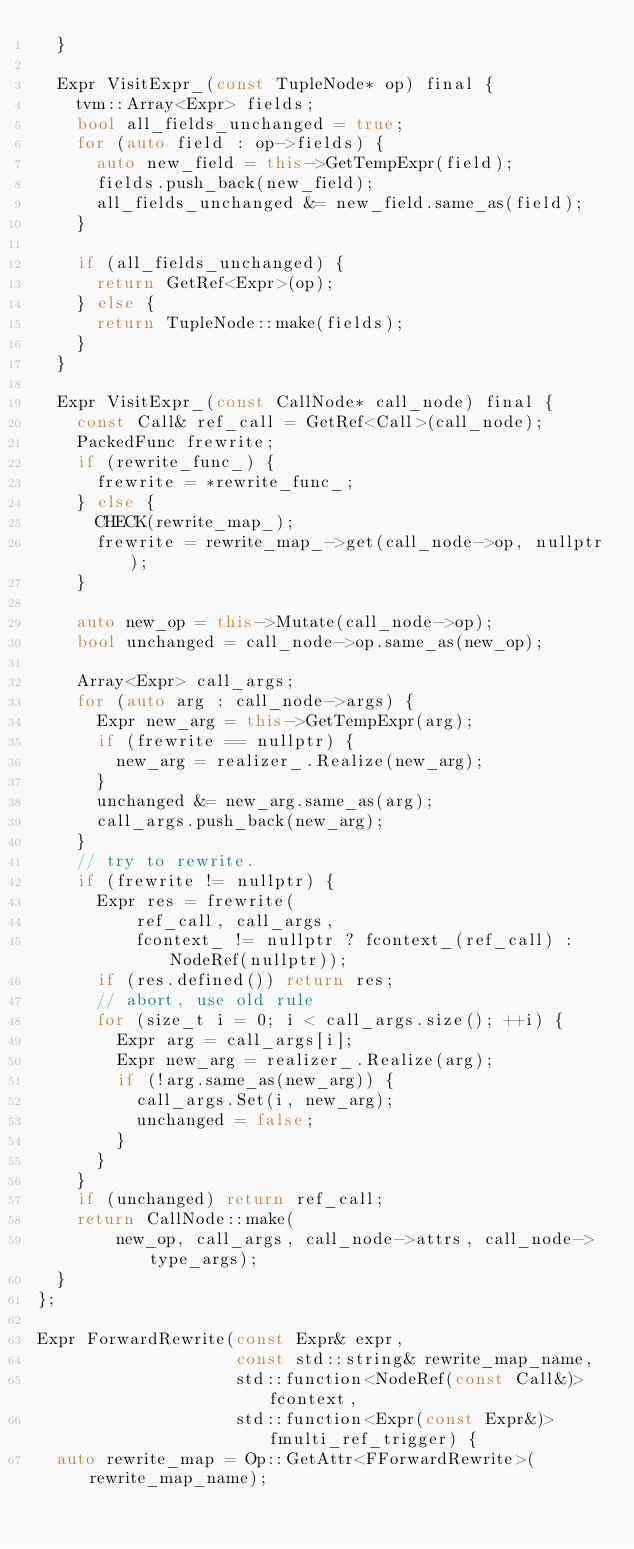<code> <loc_0><loc_0><loc_500><loc_500><_C++_>  }

  Expr VisitExpr_(const TupleNode* op) final {
    tvm::Array<Expr> fields;
    bool all_fields_unchanged = true;
    for (auto field : op->fields) {
      auto new_field = this->GetTempExpr(field);
      fields.push_back(new_field);
      all_fields_unchanged &= new_field.same_as(field);
    }

    if (all_fields_unchanged) {
      return GetRef<Expr>(op);
    } else {
      return TupleNode::make(fields);
    }
  }

  Expr VisitExpr_(const CallNode* call_node) final {
    const Call& ref_call = GetRef<Call>(call_node);
    PackedFunc frewrite;
    if (rewrite_func_) {
      frewrite = *rewrite_func_;
    } else {
      CHECK(rewrite_map_);
      frewrite = rewrite_map_->get(call_node->op, nullptr);
    }

    auto new_op = this->Mutate(call_node->op);
    bool unchanged = call_node->op.same_as(new_op);

    Array<Expr> call_args;
    for (auto arg : call_node->args) {
      Expr new_arg = this->GetTempExpr(arg);
      if (frewrite == nullptr) {
        new_arg = realizer_.Realize(new_arg);
      }
      unchanged &= new_arg.same_as(arg);
      call_args.push_back(new_arg);
    }
    // try to rewrite.
    if (frewrite != nullptr) {
      Expr res = frewrite(
          ref_call, call_args,
          fcontext_ != nullptr ? fcontext_(ref_call) : NodeRef(nullptr));
      if (res.defined()) return res;
      // abort, use old rule
      for (size_t i = 0; i < call_args.size(); ++i) {
        Expr arg = call_args[i];
        Expr new_arg = realizer_.Realize(arg);
        if (!arg.same_as(new_arg)) {
          call_args.Set(i, new_arg);
          unchanged = false;
        }
      }
    }
    if (unchanged) return ref_call;
    return CallNode::make(
        new_op, call_args, call_node->attrs, call_node->type_args);
  }
};

Expr ForwardRewrite(const Expr& expr,
                    const std::string& rewrite_map_name,
                    std::function<NodeRef(const Call&)> fcontext,
                    std::function<Expr(const Expr&)> fmulti_ref_trigger) {
  auto rewrite_map = Op::GetAttr<FForwardRewrite>(rewrite_map_name);</code> 